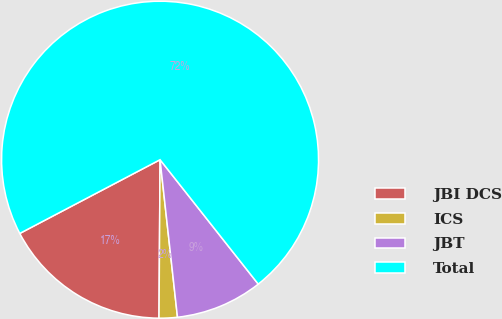Convert chart to OTSL. <chart><loc_0><loc_0><loc_500><loc_500><pie_chart><fcel>JBI DCS<fcel>ICS<fcel>JBT<fcel>Total<nl><fcel>17.19%<fcel>1.86%<fcel>8.88%<fcel>72.06%<nl></chart> 